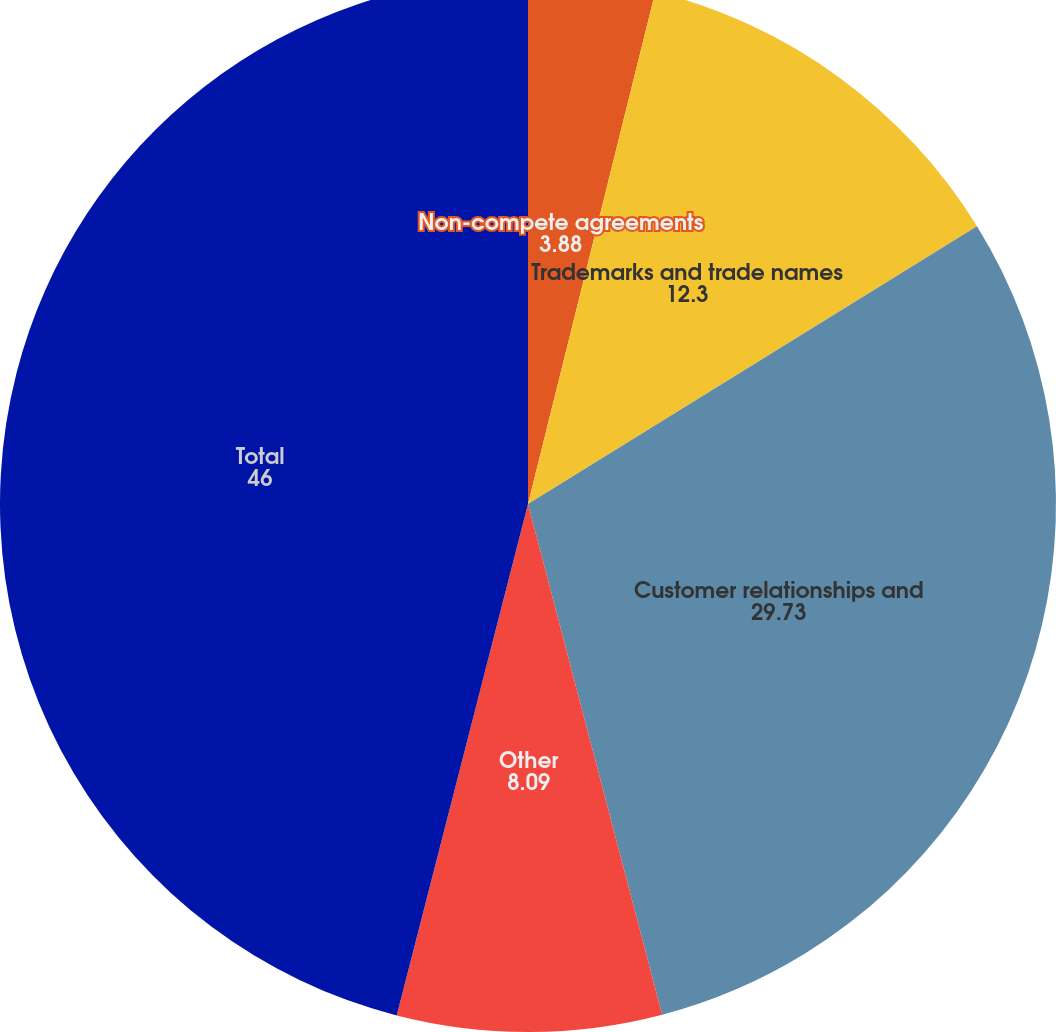<chart> <loc_0><loc_0><loc_500><loc_500><pie_chart><fcel>Non-compete agreements<fcel>Trademarks and trade names<fcel>Customer relationships and<fcel>Other<fcel>Total<nl><fcel>3.88%<fcel>12.3%<fcel>29.73%<fcel>8.09%<fcel>46.0%<nl></chart> 